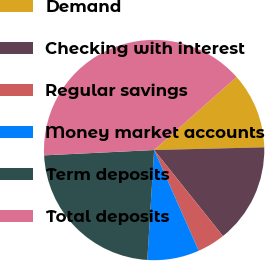Convert chart. <chart><loc_0><loc_0><loc_500><loc_500><pie_chart><fcel>Demand<fcel>Checking with interest<fcel>Regular savings<fcel>Money market accounts<fcel>Term deposits<fcel>Total deposits<nl><fcel>11.14%<fcel>14.65%<fcel>4.11%<fcel>7.62%<fcel>23.24%<fcel>39.23%<nl></chart> 